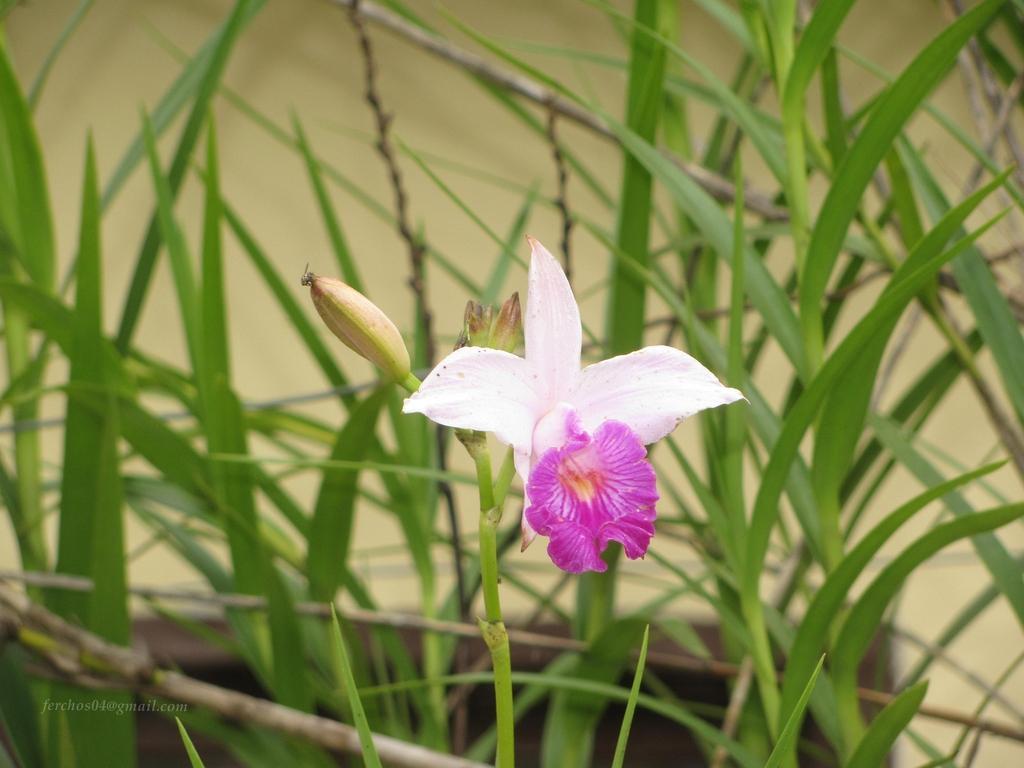How would you summarize this image in a sentence or two? In this picture I can see a flower, there are buds, there are leaves, and there is blur background and there is a watermark on the image. 